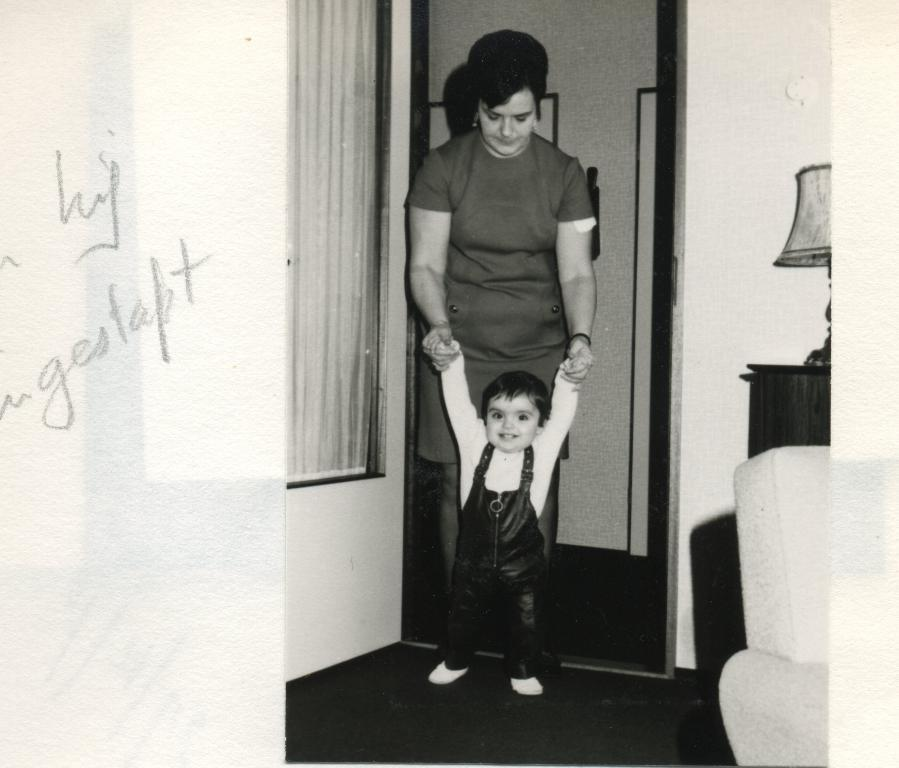What is the color scheme of the image? The image is black and white. Who can be seen in the image? There is a lady and a child in the image. What architectural feature is present in the image? There is a door in the image. What is written or drawn on the wall in the image? There is text on the wall in the image. What type of lighting is visible in the image? There is a lamp on the right side of the image. Can you see any turkeys or railway tracks in the image? No, there are no turkeys or railway tracks present in the image. How many trucks are visible in the image? There are no trucks visible in the image. 